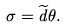Convert formula to latex. <formula><loc_0><loc_0><loc_500><loc_500>\sigma = \widetilde { d } \theta .</formula> 